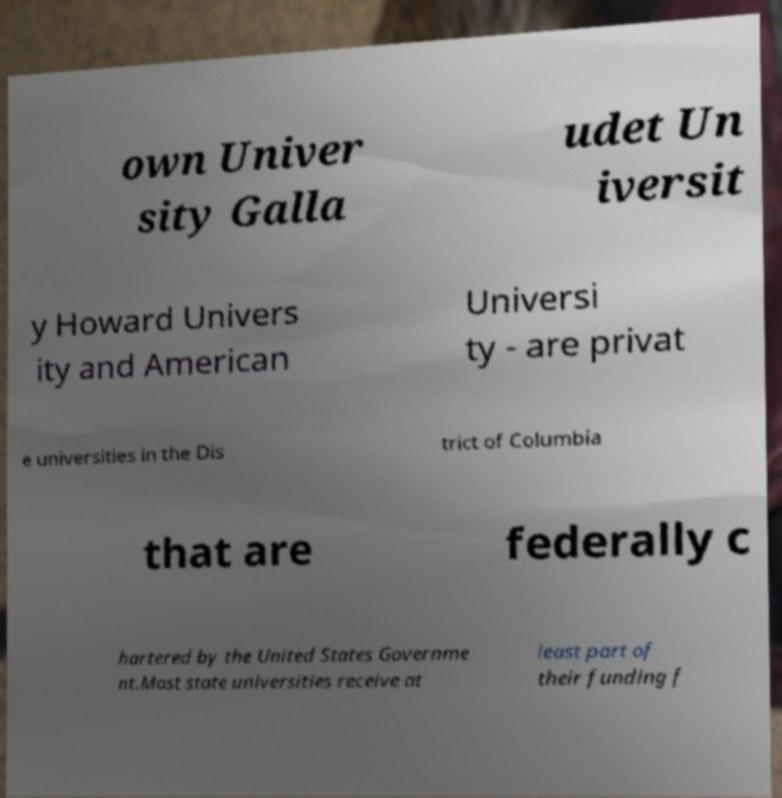I need the written content from this picture converted into text. Can you do that? own Univer sity Galla udet Un iversit y Howard Univers ity and American Universi ty - are privat e universities in the Dis trict of Columbia that are federally c hartered by the United States Governme nt.Most state universities receive at least part of their funding f 